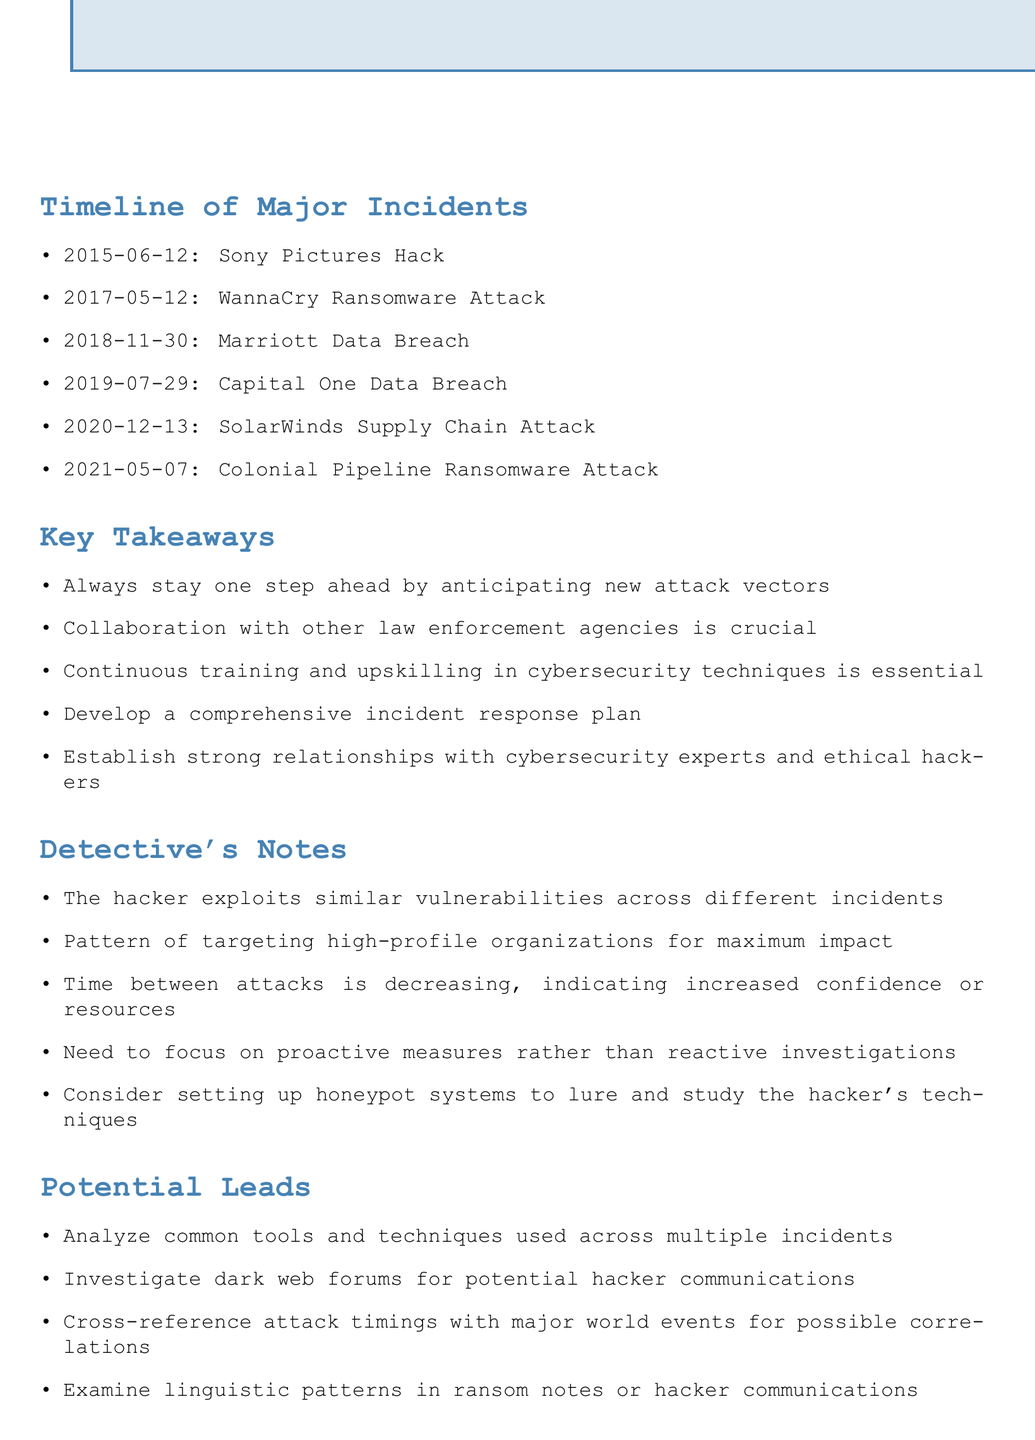what date did the Sony Pictures hack occur? The date of the Sony Pictures hack is listed in the timeline section of the document.
Answer: 2015-06-12 how many guests were affected in the Marriott data breach? The number of guests affected is found in the details of the Marriott Data Breach incident.
Answer: 500 million which incident involved a ransomware attack in May 2021? This question requires reasoning about the timeline to see which incident correlates with the date in May 2021.
Answer: Colonial Pipeline Ransomware Attack what was a missed opportunity in the WannaCry ransomware attack? The missed opportunity can be found next to the incident details in the timeline.
Answer: Overlooked the importance of timely software updates name one key takeaway from the document. The key takeaways section lists important lessons learned from the incidents.
Answer: Always stay one step ahead by anticipating new attack vectors how many incidents are listed in the timeline? The total number of incidents can be counted in the timeline section of the document.
Answer: 6 what lesson was learned from the Capital One data breach? Each incident has a corresponding lesson learned that reflects on the mistakes made; this pertains to the Capital One incident.
Answer: Regularly audit and test security configurations which hacker tactic was indicated by the detective's notes? The notes contain observations about the hacker's approach and tactics across incidents.
Answer: Exploits similar vulnerabilities what should be established according to the lesson learned from the SolarWinds attack? The lesson learned identifies necessary practices to mitigate risks from third-party software.
Answer: Implement rigorous vendor risk management practices 